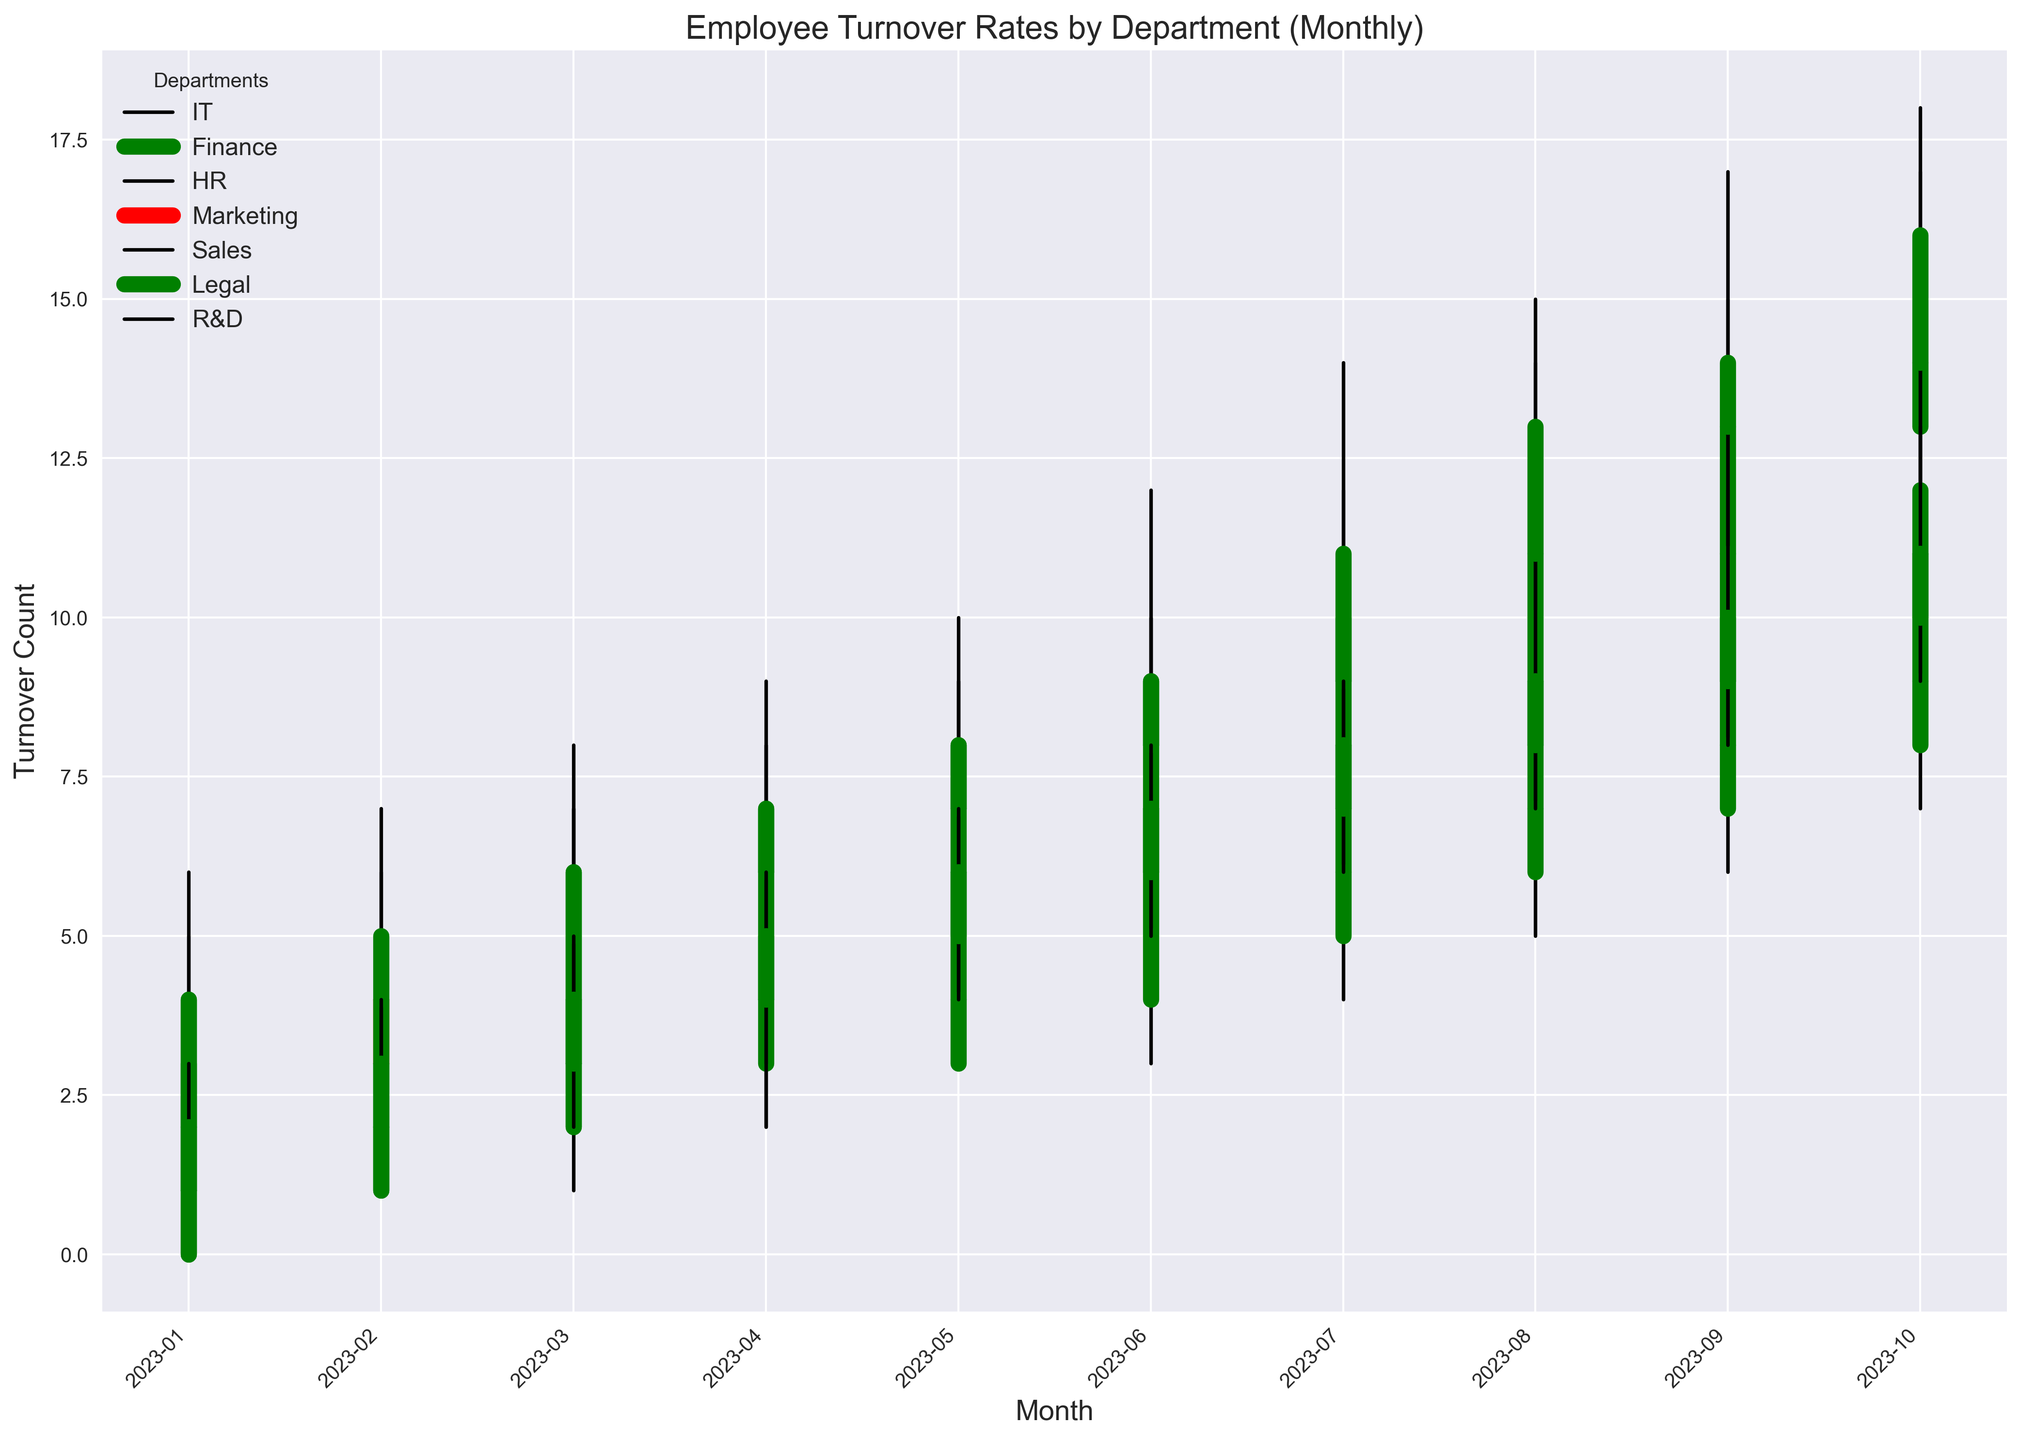What is the highest employee turnover rate observed in the IT department over the year? To find the highest turnover rate in the IT department, refer to the highest "High" value in the IT department data points. The maximum "High" value for IT is 17, observed in October.
Answer: 17 Which department had the highest closing turnover rate in October 2023? To determine the department with the highest closing turnover rate in October, look for the highest "Close" value among all departments in October. Sales has the highest closing turnover rate with a value of 16.
Answer: Sales What is the average closing turnover rate for the IT department from January to March 2023? Calculate the average by summing the closing turnover rates for IT in January, February, and March (4 + 3 + 6) and then divide by 3. (4 + 3 + 6) / 3 = 13 / 3 = 4.33
Answer: 4.33 Which department showed the most significant increase in turnover rate from January to October 2023? To find the department with the most significant increase, compare the difference between the closing rates in January and October for each department. The largest difference is observed in Sales with an increase from 4 in January to 16 in October (16 - 4 = 12).
Answer: Sales Between IT and Finance, which department had a higher turnover rate in June 2023? Compare the closing turnover rate of IT and Finance in June 2023. IT's closing rate is 9, and Finance's closing rate is 7. Thus, IT had the higher rate.
Answer: IT What’s the average monthly closing turnover rate for the HR department from July to September 2023? Calculate the average by summing the closing turnover rates for HR in July, August, and September (7 + 8 + 9) and then divide by 3. (7 + 8 + 9) / 3 = 24 / 3 = 8
Answer: 8 Which department experienced a decrease in turnover rate in October 2023 compared to the previous month? Compare the closing turnover rates in September and October for each department. Only "Legal" showed a decrease from 9 in September to 7 in October.
Answer: Legal What is the cumulative turnover rate for the Marketing department from January to June 2023? Sum the closing turnover rates for Marketing from January to June (3 + 4 + 5 + 6 + 7 + 8). The sum is 33.
Answer: 33 Among IT, HR, and Sales, which department had the lowest low turnover rate in February 2023? Compare the "Low" values for IT, HR, and Sales in February 2023. The low values are 2 for IT, 1 for HR, and 3 for Sales. Therefore, HR had the lowest low turnover rate.
Answer: HR What is the sum of the highest turnover rates for each department in July 2023? Add the highest turnover rates ("High" values) for each department in July 2023. The values are IT: 12, Finance: 9, HR: 8, Marketing: 11, Sales: 14, Legal: 7, R&D: 9. The sum is 70.
Answer: 70 